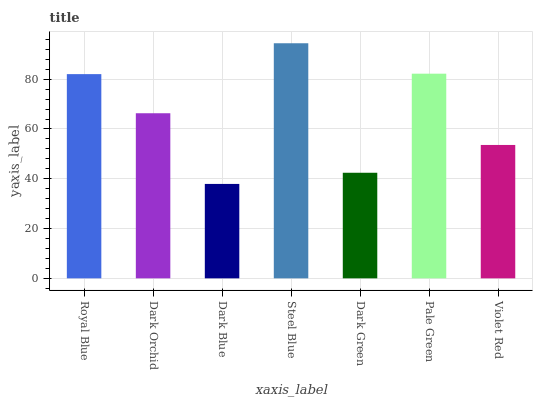Is Dark Blue the minimum?
Answer yes or no. Yes. Is Steel Blue the maximum?
Answer yes or no. Yes. Is Dark Orchid the minimum?
Answer yes or no. No. Is Dark Orchid the maximum?
Answer yes or no. No. Is Royal Blue greater than Dark Orchid?
Answer yes or no. Yes. Is Dark Orchid less than Royal Blue?
Answer yes or no. Yes. Is Dark Orchid greater than Royal Blue?
Answer yes or no. No. Is Royal Blue less than Dark Orchid?
Answer yes or no. No. Is Dark Orchid the high median?
Answer yes or no. Yes. Is Dark Orchid the low median?
Answer yes or no. Yes. Is Dark Green the high median?
Answer yes or no. No. Is Royal Blue the low median?
Answer yes or no. No. 